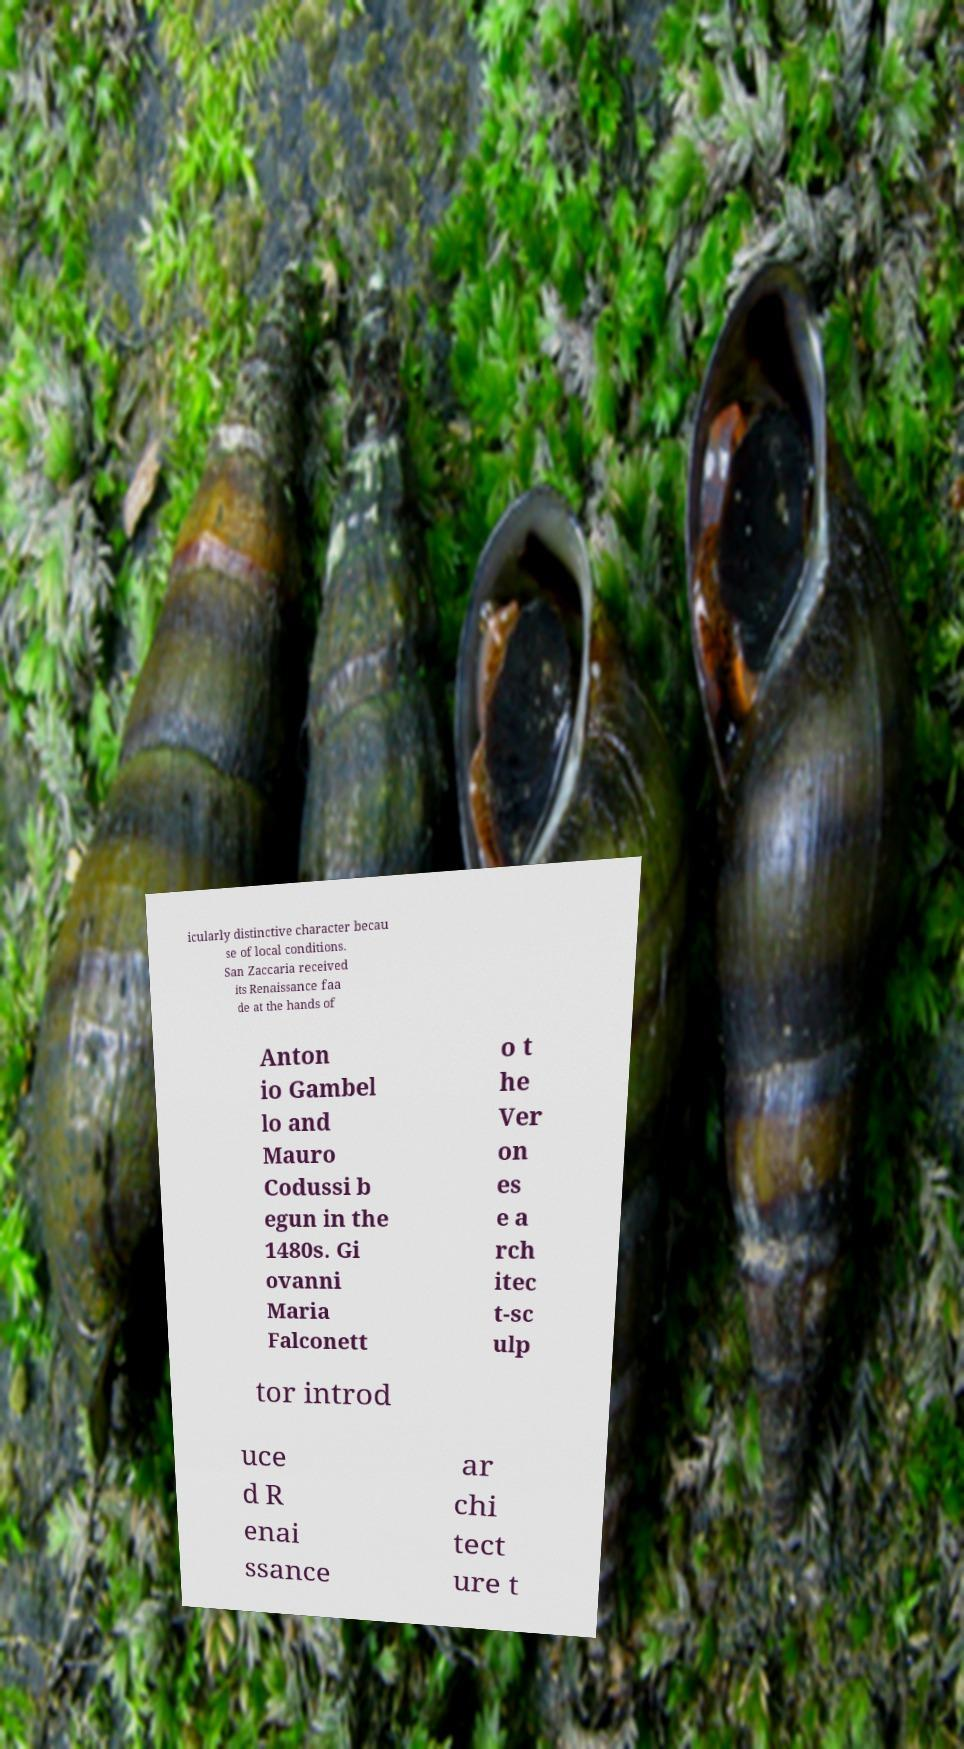Could you extract and type out the text from this image? icularly distinctive character becau se of local conditions. San Zaccaria received its Renaissance faa de at the hands of Anton io Gambel lo and Mauro Codussi b egun in the 1480s. Gi ovanni Maria Falconett o t he Ver on es e a rch itec t-sc ulp tor introd uce d R enai ssance ar chi tect ure t 